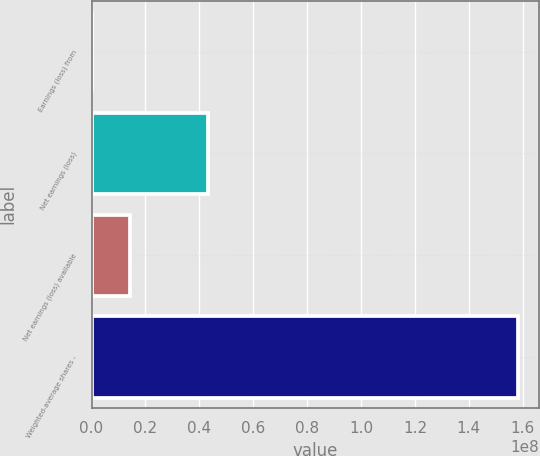Convert chart to OTSL. <chart><loc_0><loc_0><loc_500><loc_500><bar_chart><fcel>Earnings (loss) from<fcel>Net earnings (loss)<fcel>Net earnings (loss) available<fcel>Weighted-average shares -<nl><fcel>4<fcel>4.31066e+07<fcel>1.43689e+07<fcel>1.58058e+08<nl></chart> 